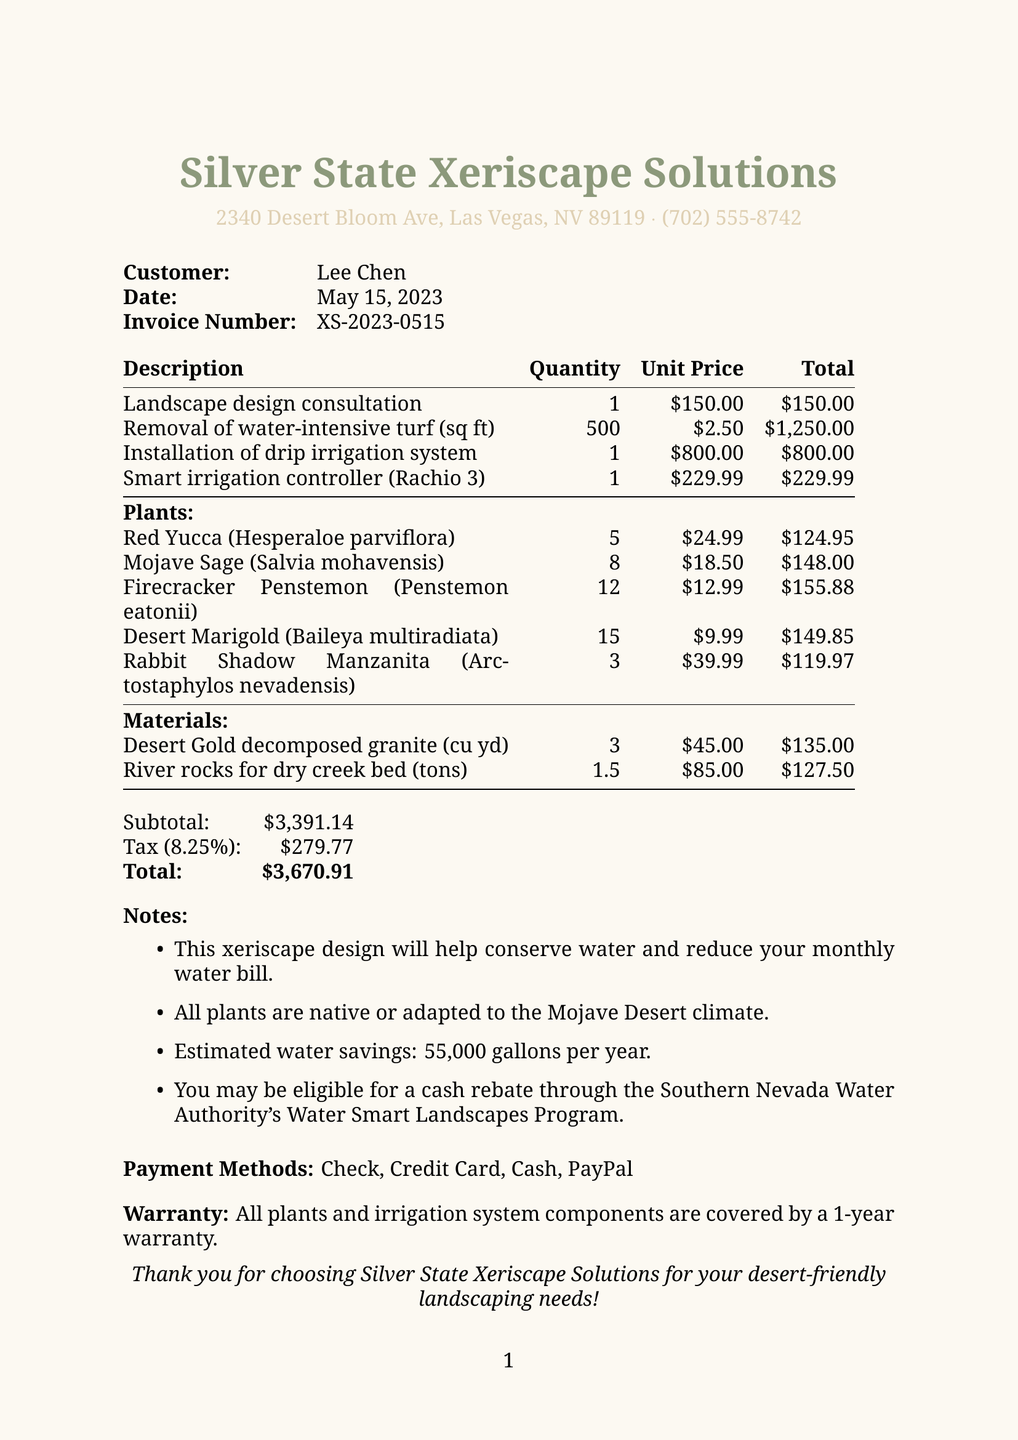What is the company name? The company name is clearly stated at the top of the receipt.
Answer: Silver State Xeriscape Solutions What is the total amount? The total amount is provided in the summary section at the bottom of the receipt.
Answer: $3,670.91 What is the date of the service? The date is mentioned in the header section of the receipt.
Answer: May 15, 2023 How many plants are listed? The number of plants can be counted from the section where plants are detailed.
Answer: 5 What is the quantity of Desert Marigold? The quantity of Desert Marigold is specified in the plants section.
Answer: 15 What is the warranty period for the plants? The warranty information can be found towards the end of the document.
Answer: 1-year What is the tax rate? The tax rate is explicitly stated in the subtotal section.
Answer: 8.25% What is the subtotal before tax? The subtotal is provided just before the tax and total amounts.
Answer: $3,391.14 What type of payment methods are accepted? The document lists accepted payment methods towards the end.
Answer: Check, Credit Card, Cash, PayPal 